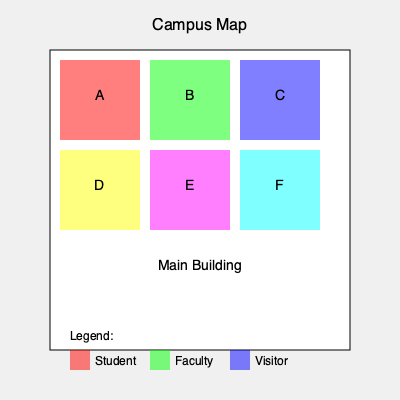Given the campus map with highlighted parking zones, which parking area would be most suitable for you as a first-year student, and how many different parking zone types are available on campus? To answer this question, we need to analyze the campus map and its legend:

1. Identify the parking zones:
   - Zone A: Red
   - Zone B: Green
   - Zone C: Blue
   - Zone D: Yellow
   - Zone E: Purple
   - Zone F: Cyan

2. Check the legend:
   - Red: Student parking
   - Green: Faculty parking
   - Blue: Visitor parking

3. Determine the most suitable parking area:
   As a first-year student, you should park in the student parking area, which is Zone A (red).

4. Count the different parking zone types:
   - Student (red)
   - Faculty (green)
   - Visitor (blue)
   - Three unlabeled types (yellow, purple, cyan)

   Total number of different parking zone types: $3 + 3 = 6$

Therefore, the most suitable parking area for a first-year student is Zone A, and there are 6 different parking zone types available on campus.
Answer: Zone A; 6 types 